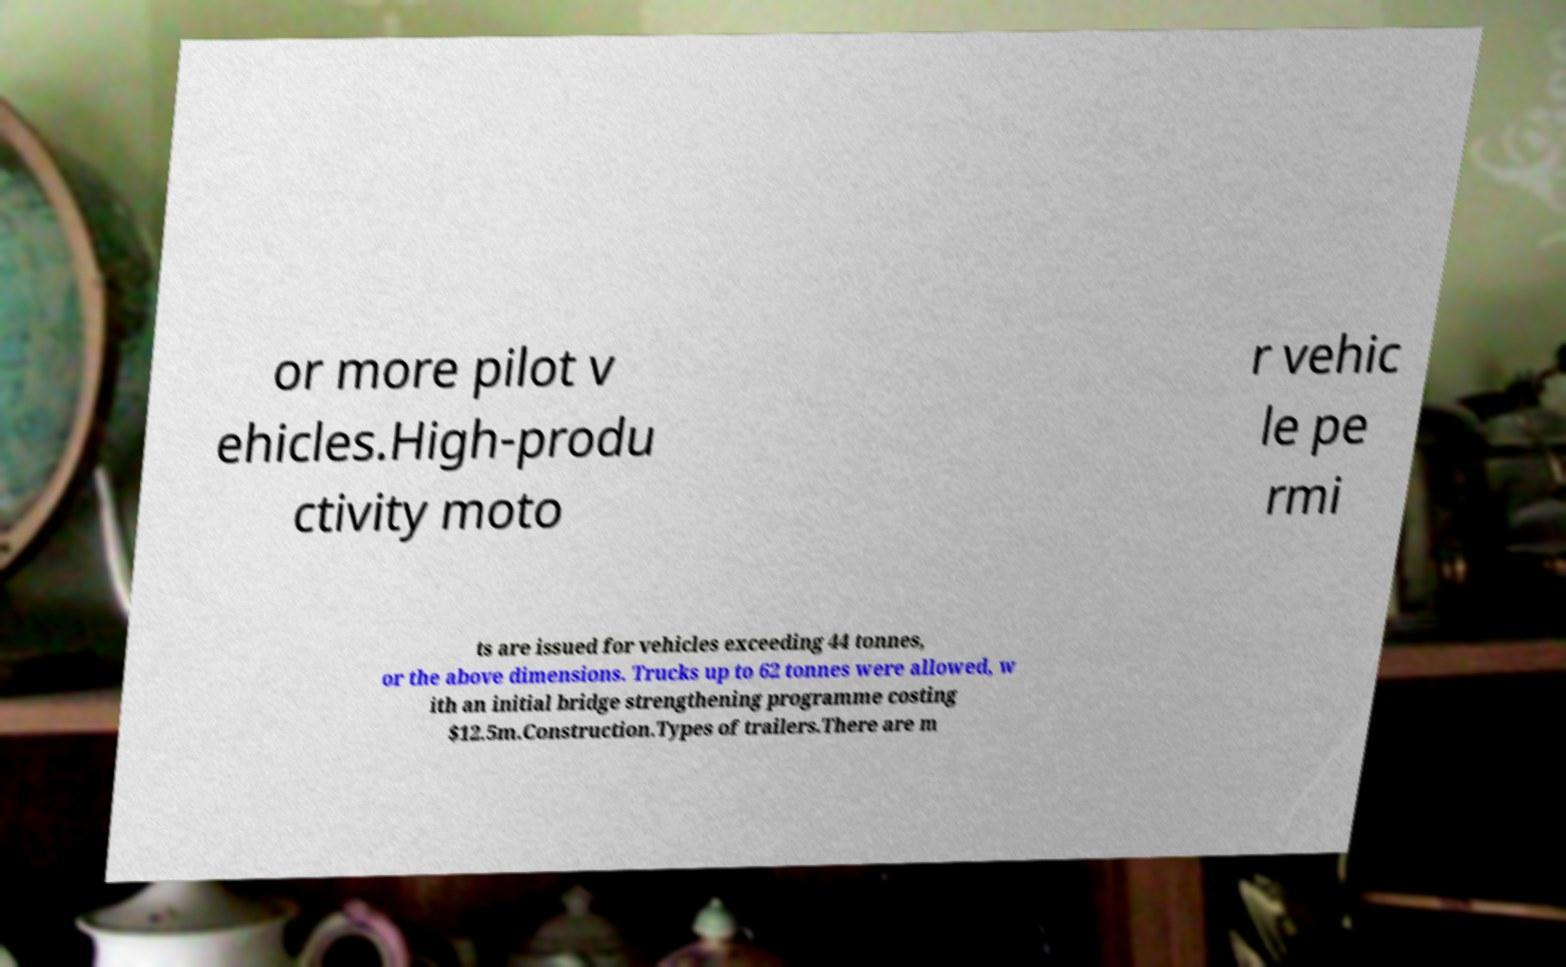For documentation purposes, I need the text within this image transcribed. Could you provide that? or more pilot v ehicles.High-produ ctivity moto r vehic le pe rmi ts are issued for vehicles exceeding 44 tonnes, or the above dimensions. Trucks up to 62 tonnes were allowed, w ith an initial bridge strengthening programme costing $12.5m.Construction.Types of trailers.There are m 